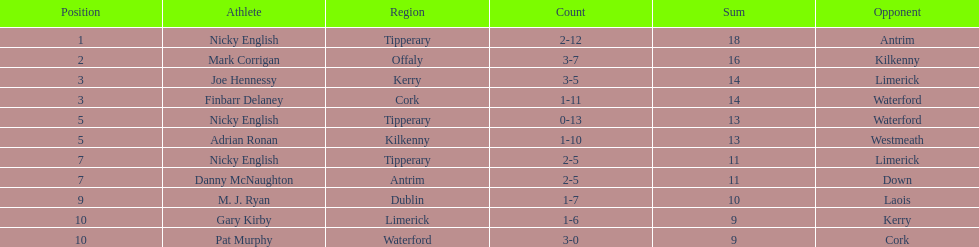What player got 10 total points in their game? M. J. Ryan. 